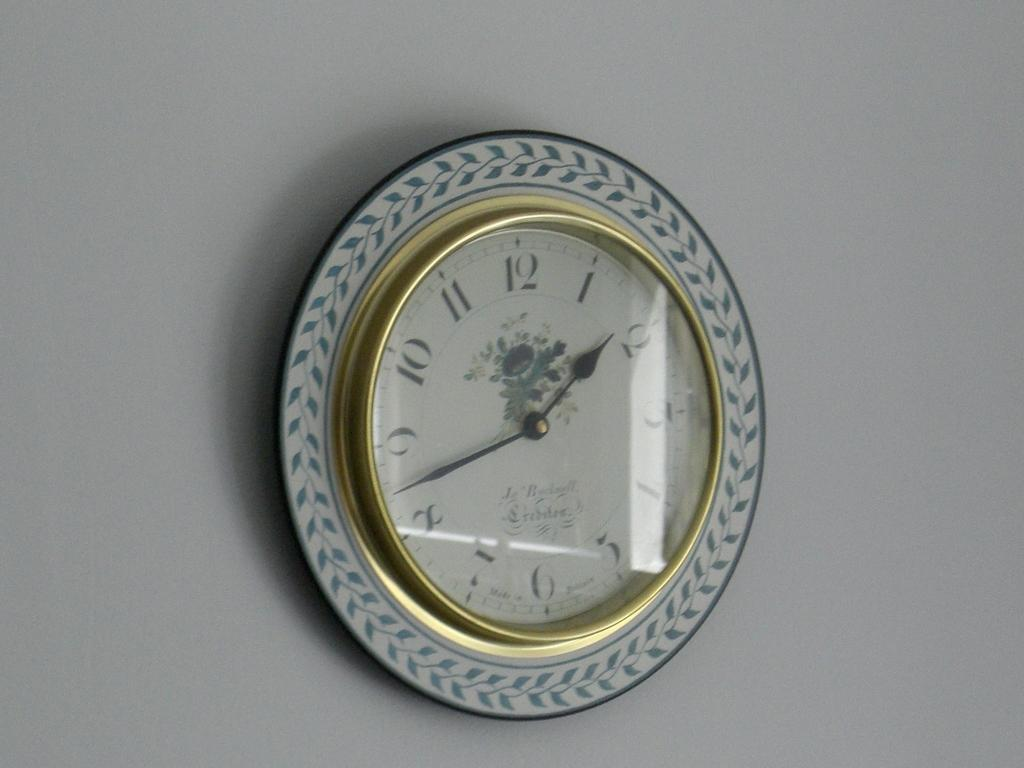<image>
Relay a brief, clear account of the picture shown. A round white clock on the wall reads 1:42. 